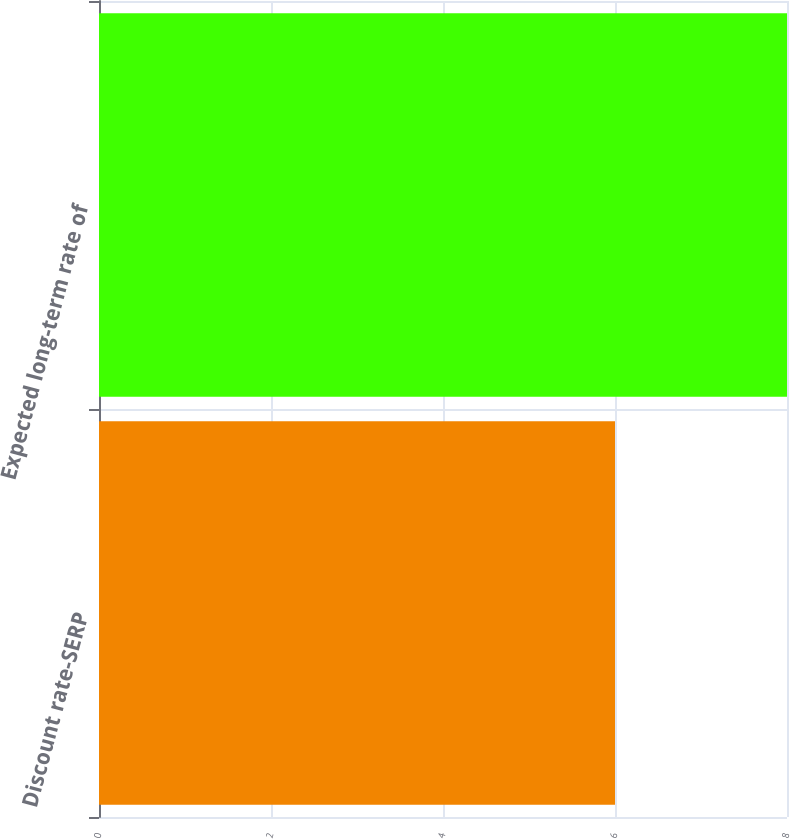Convert chart to OTSL. <chart><loc_0><loc_0><loc_500><loc_500><bar_chart><fcel>Discount rate-SERP<fcel>Expected long-term rate of<nl><fcel>6<fcel>8<nl></chart> 